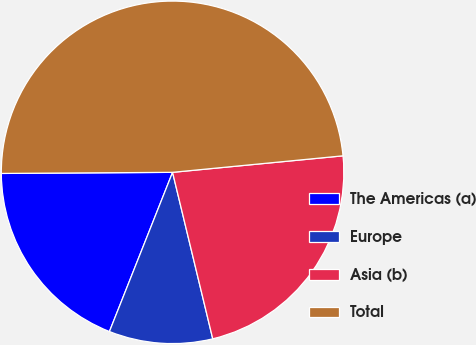<chart> <loc_0><loc_0><loc_500><loc_500><pie_chart><fcel>The Americas (a)<fcel>Europe<fcel>Asia (b)<fcel>Total<nl><fcel>18.89%<fcel>9.78%<fcel>22.77%<fcel>48.57%<nl></chart> 